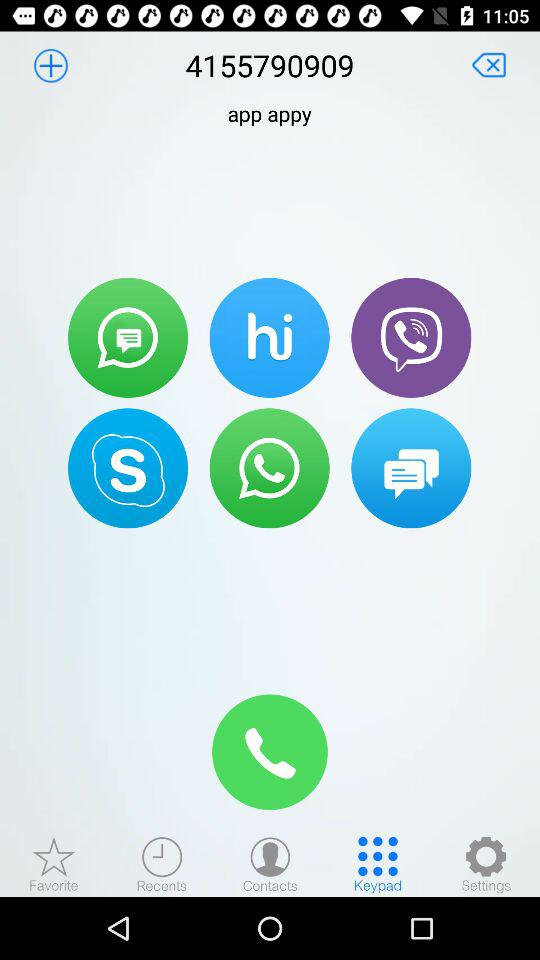Which tab has been selected? The tab that has been selected is "Keypad". 